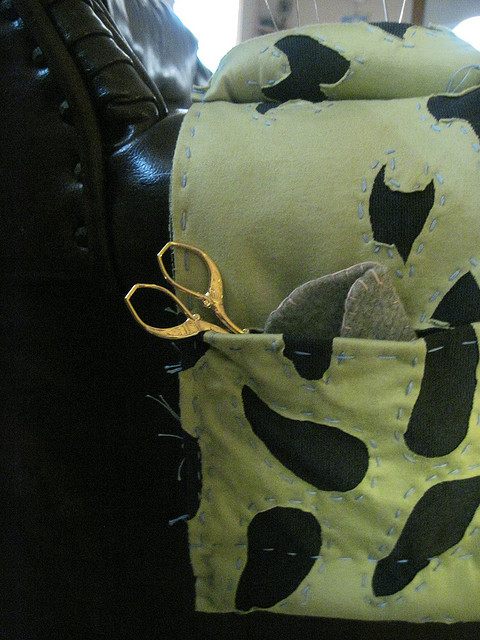<image>What is the patches made of? I don't know what the patches are made of. It could be fabric, material, cloth, or felt. What is the patches made of? I am not sure what the patches are made of. It can be fabric, material, cloth, footprints, socks, felt, black fabric or any other material. 